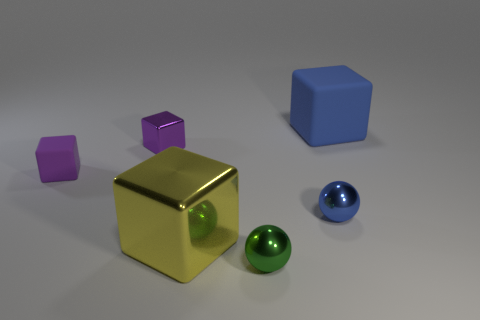Add 4 green balls. How many objects exist? 10 Subtract all purple rubber blocks. How many blocks are left? 3 Subtract 0 green cylinders. How many objects are left? 6 Subtract all balls. How many objects are left? 4 Subtract 3 blocks. How many blocks are left? 1 Subtract all yellow spheres. Subtract all red cubes. How many spheres are left? 2 Subtract all blue spheres. How many blue cubes are left? 1 Subtract all big metallic cubes. Subtract all large yellow metallic blocks. How many objects are left? 4 Add 4 yellow metallic objects. How many yellow metallic objects are left? 5 Add 3 big blue cubes. How many big blue cubes exist? 4 